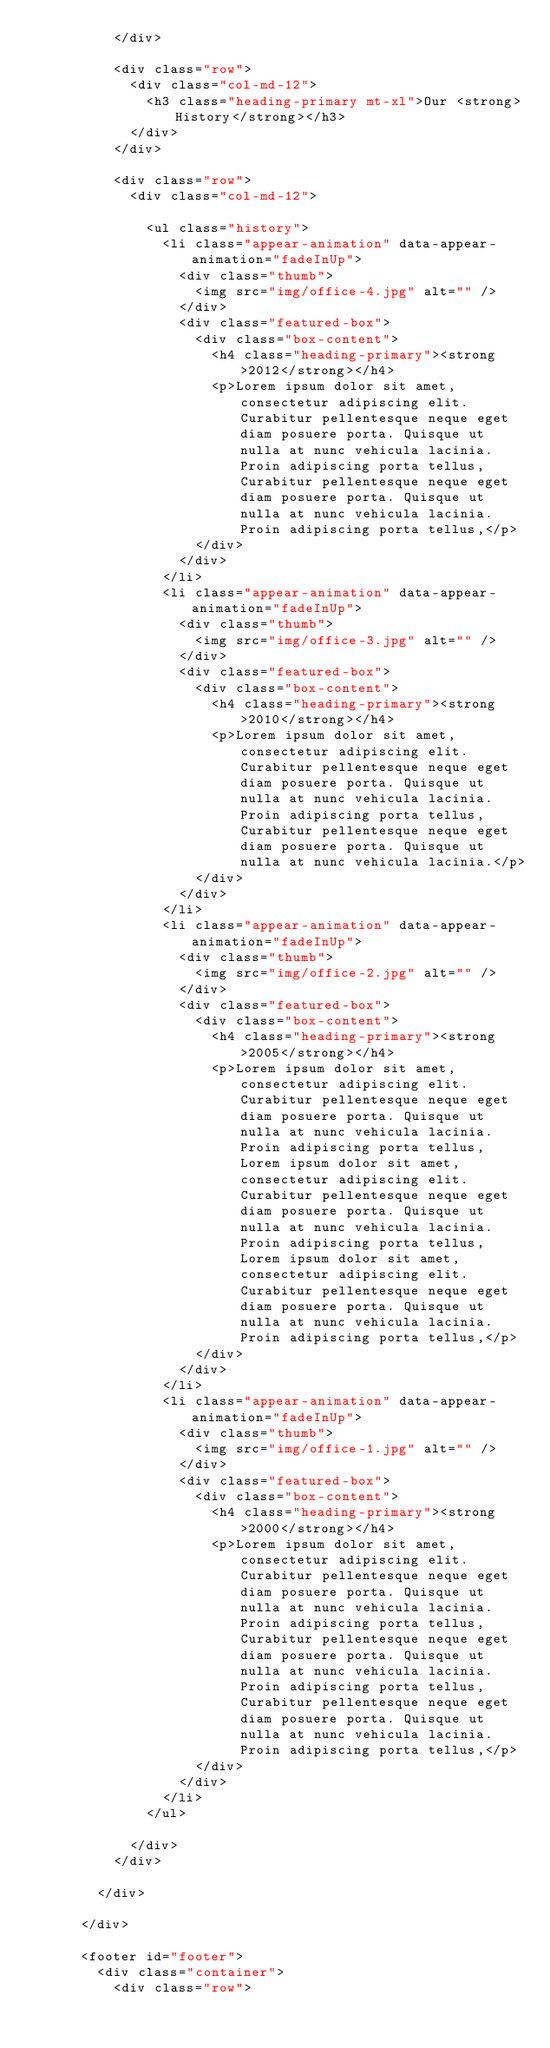<code> <loc_0><loc_0><loc_500><loc_500><_PHP_>					</div>

					<div class="row">
						<div class="col-md-12">
							<h3 class="heading-primary mt-xl">Our <strong>History</strong></h3>
						</div>
					</div>

					<div class="row">
						<div class="col-md-12">

							<ul class="history">
								<li class="appear-animation" data-appear-animation="fadeInUp">
									<div class="thumb">
										<img src="img/office-4.jpg" alt="" />
									</div>
									<div class="featured-box">
										<div class="box-content">
											<h4 class="heading-primary"><strong>2012</strong></h4>
											<p>Lorem ipsum dolor sit amet, consectetur adipiscing elit. Curabitur pellentesque neque eget diam posuere porta. Quisque ut nulla at nunc vehicula lacinia. Proin adipiscing porta tellus, Curabitur pellentesque neque eget diam posuere porta. Quisque ut nulla at nunc vehicula lacinia. Proin adipiscing porta tellus,</p>
										</div>
									</div>
								</li>
								<li class="appear-animation" data-appear-animation="fadeInUp">
									<div class="thumb">
										<img src="img/office-3.jpg" alt="" />
									</div>
									<div class="featured-box">
										<div class="box-content">
											<h4 class="heading-primary"><strong>2010</strong></h4>
											<p>Lorem ipsum dolor sit amet, consectetur adipiscing elit. Curabitur pellentesque neque eget diam posuere porta. Quisque ut nulla at nunc vehicula lacinia. Proin adipiscing porta tellus, Curabitur pellentesque neque eget diam posuere porta. Quisque ut nulla at nunc vehicula lacinia.</p>
										</div>
									</div>
								</li>
								<li class="appear-animation" data-appear-animation="fadeInUp">
									<div class="thumb">
										<img src="img/office-2.jpg" alt="" />
									</div>
									<div class="featured-box">
										<div class="box-content">
											<h4 class="heading-primary"><strong>2005</strong></h4>
											<p>Lorem ipsum dolor sit amet, consectetur adipiscing elit. Curabitur pellentesque neque eget diam posuere porta. Quisque ut nulla at nunc vehicula lacinia. Proin adipiscing porta tellus, Lorem ipsum dolor sit amet, consectetur adipiscing elit. Curabitur pellentesque neque eget diam posuere porta. Quisque ut nulla at nunc vehicula lacinia. Proin adipiscing porta tellus, Lorem ipsum dolor sit amet, consectetur adipiscing elit. Curabitur pellentesque neque eget diam posuere porta. Quisque ut nulla at nunc vehicula lacinia. Proin adipiscing porta tellus,</p>
										</div>
									</div>
								</li>
								<li class="appear-animation" data-appear-animation="fadeInUp">
									<div class="thumb">
										<img src="img/office-1.jpg" alt="" />
									</div>
									<div class="featured-box">
										<div class="box-content">
											<h4 class="heading-primary"><strong>2000</strong></h4>
											<p>Lorem ipsum dolor sit amet, consectetur adipiscing elit. Curabitur pellentesque neque eget diam posuere porta. Quisque ut nulla at nunc vehicula lacinia. Proin adipiscing porta tellus, Curabitur pellentesque neque eget diam posuere porta. Quisque ut nulla at nunc vehicula lacinia. Proin adipiscing porta tellus, Curabitur pellentesque neque eget diam posuere porta. Quisque ut nulla at nunc vehicula lacinia. Proin adipiscing porta tellus,</p>
										</div>
									</div>
								</li>
							</ul>

						</div>
					</div>

				</div>

			</div>

			<footer id="footer">
				<div class="container">
					<div class="row"></code> 